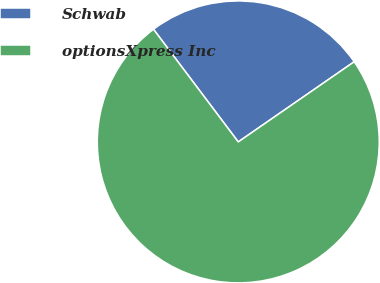Convert chart to OTSL. <chart><loc_0><loc_0><loc_500><loc_500><pie_chart><fcel>Schwab<fcel>optionsXpress Inc<nl><fcel>25.64%<fcel>74.36%<nl></chart> 